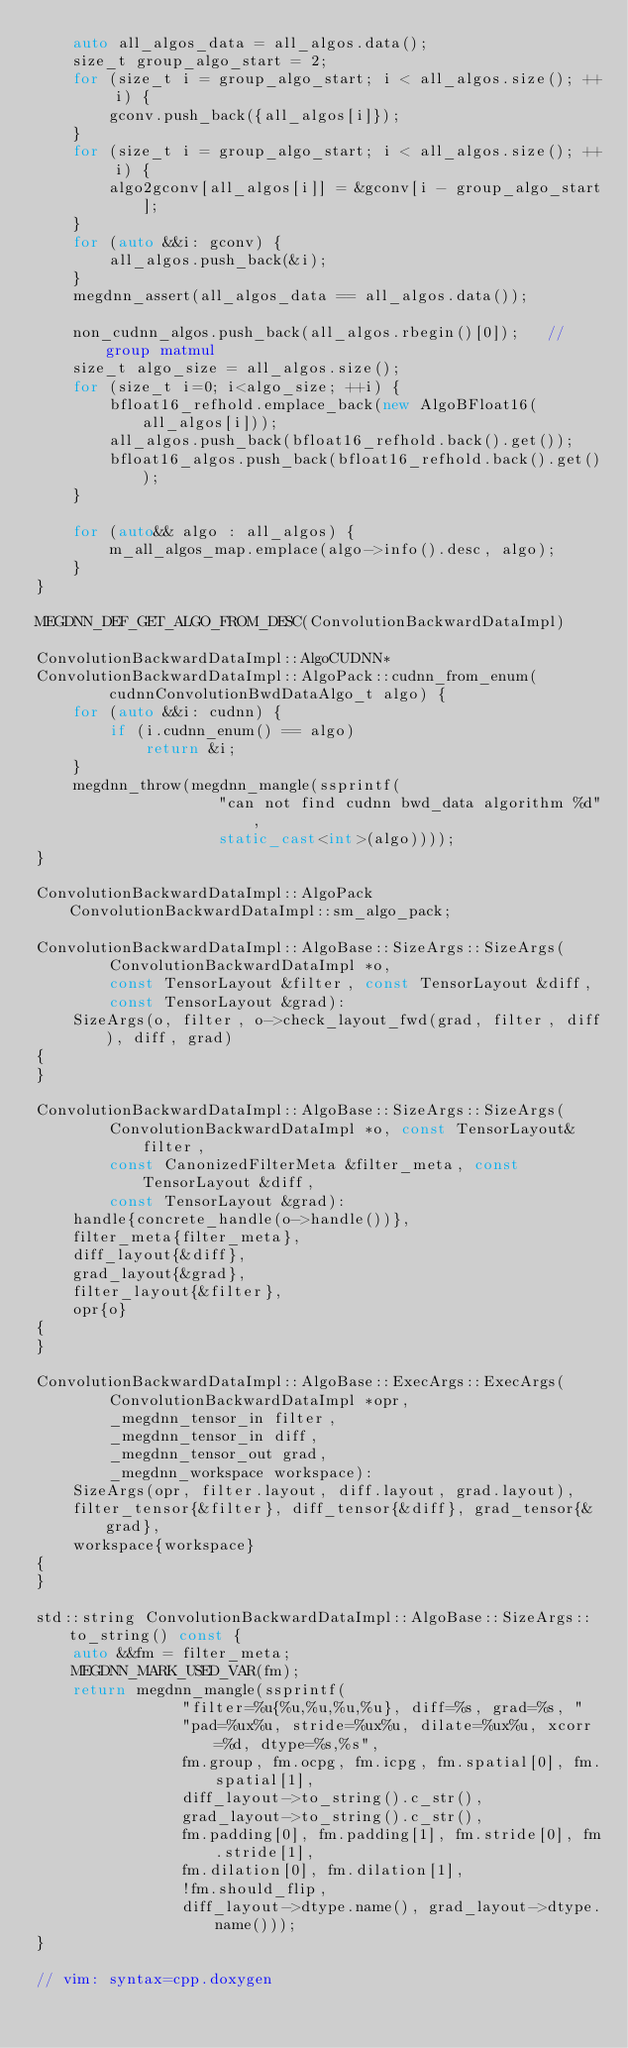<code> <loc_0><loc_0><loc_500><loc_500><_C++_>    auto all_algos_data = all_algos.data();
    size_t group_algo_start = 2;
    for (size_t i = group_algo_start; i < all_algos.size(); ++ i) {
        gconv.push_back({all_algos[i]});
    }
    for (size_t i = group_algo_start; i < all_algos.size(); ++ i) {
        algo2gconv[all_algos[i]] = &gconv[i - group_algo_start];
    }
    for (auto &&i: gconv) {
        all_algos.push_back(&i);
    }
    megdnn_assert(all_algos_data == all_algos.data());

    non_cudnn_algos.push_back(all_algos.rbegin()[0]);   // group matmul
    size_t algo_size = all_algos.size();
    for (size_t i=0; i<algo_size; ++i) {
        bfloat16_refhold.emplace_back(new AlgoBFloat16(all_algos[i]));
        all_algos.push_back(bfloat16_refhold.back().get());
        bfloat16_algos.push_back(bfloat16_refhold.back().get());
    }

    for (auto&& algo : all_algos) {
        m_all_algos_map.emplace(algo->info().desc, algo);
    }
}

MEGDNN_DEF_GET_ALGO_FROM_DESC(ConvolutionBackwardDataImpl)

ConvolutionBackwardDataImpl::AlgoCUDNN*
ConvolutionBackwardDataImpl::AlgoPack::cudnn_from_enum(
        cudnnConvolutionBwdDataAlgo_t algo) {
    for (auto &&i: cudnn) {
        if (i.cudnn_enum() == algo)
            return &i;
    }
    megdnn_throw(megdnn_mangle(ssprintf(
                    "can not find cudnn bwd_data algorithm %d",
                    static_cast<int>(algo))));
}

ConvolutionBackwardDataImpl::AlgoPack ConvolutionBackwardDataImpl::sm_algo_pack;

ConvolutionBackwardDataImpl::AlgoBase::SizeArgs::SizeArgs(
        ConvolutionBackwardDataImpl *o,
        const TensorLayout &filter, const TensorLayout &diff,
        const TensorLayout &grad):
    SizeArgs(o, filter, o->check_layout_fwd(grad, filter, diff), diff, grad)
{
}

ConvolutionBackwardDataImpl::AlgoBase::SizeArgs::SizeArgs(
        ConvolutionBackwardDataImpl *o, const TensorLayout& filter,
        const CanonizedFilterMeta &filter_meta, const TensorLayout &diff,
        const TensorLayout &grad):
    handle{concrete_handle(o->handle())},
    filter_meta{filter_meta},
    diff_layout{&diff},
    grad_layout{&grad},
    filter_layout{&filter},
    opr{o}
{
}

ConvolutionBackwardDataImpl::AlgoBase::ExecArgs::ExecArgs(
        ConvolutionBackwardDataImpl *opr,
        _megdnn_tensor_in filter,
        _megdnn_tensor_in diff,
        _megdnn_tensor_out grad,
        _megdnn_workspace workspace):
    SizeArgs(opr, filter.layout, diff.layout, grad.layout),
    filter_tensor{&filter}, diff_tensor{&diff}, grad_tensor{&grad},
    workspace{workspace}
{
}

std::string ConvolutionBackwardDataImpl::AlgoBase::SizeArgs::to_string() const {
    auto &&fm = filter_meta;
    MEGDNN_MARK_USED_VAR(fm);
    return megdnn_mangle(ssprintf(
                "filter=%u{%u,%u,%u,%u}, diff=%s, grad=%s, "
                "pad=%ux%u, stride=%ux%u, dilate=%ux%u, xcorr=%d, dtype=%s,%s",
                fm.group, fm.ocpg, fm.icpg, fm.spatial[0], fm.spatial[1],
                diff_layout->to_string().c_str(),
                grad_layout->to_string().c_str(),
                fm.padding[0], fm.padding[1], fm.stride[0], fm.stride[1],
                fm.dilation[0], fm.dilation[1],
                !fm.should_flip,
                diff_layout->dtype.name(), grad_layout->dtype.name()));
}

// vim: syntax=cpp.doxygen
</code> 